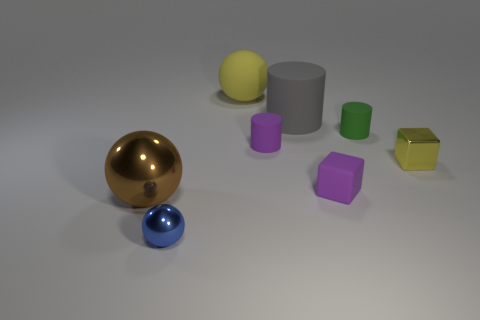How many objects are there in total in the image? There are a total of six objects in the image.  Can you describe the shapes of the objects? Certainly, the objects consist of a sphere, a cube, a cylinder, and three additional shapes that resemble a rectangular prism, or cuboids of varying sizes. 